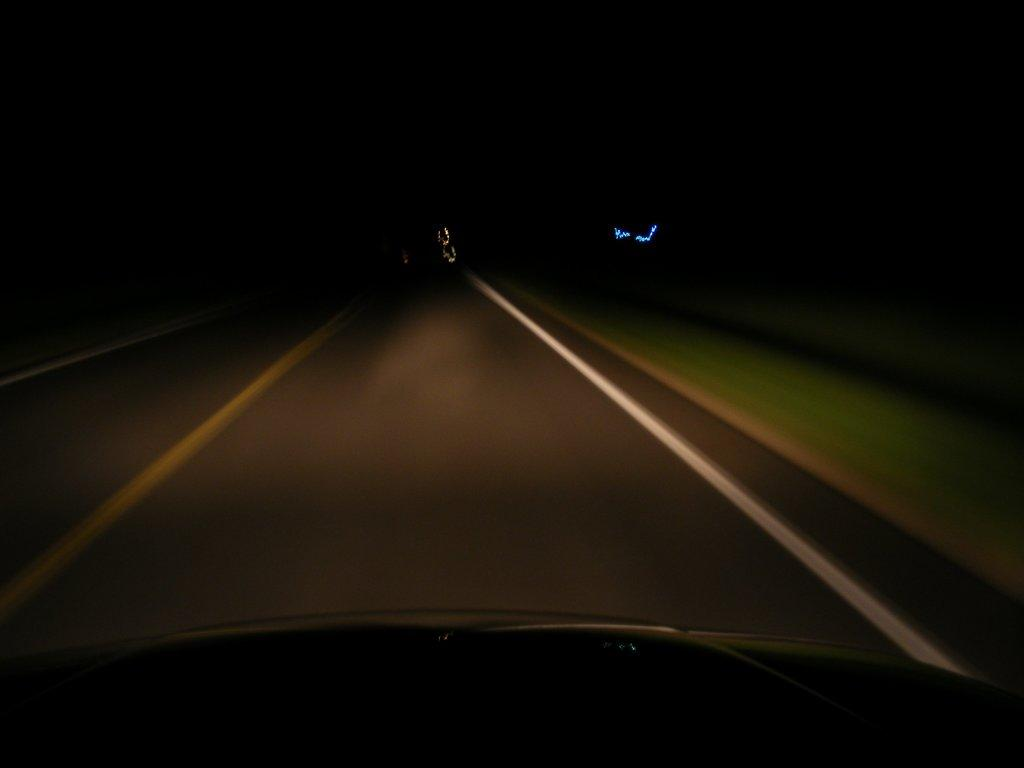What is the main feature of the image? There is a road in the image. What can be seen beside the road? The ground beside the road is covered with grass. How is the view in the image being observed? The view is seen through a car present on the road. Is the road made of quicksand in the image? No, the road is not made of quicksand; it is a regular road. Can you hear the sound of glass breaking in the image? There is no reference to any sound, including glass breaking, in the image. 